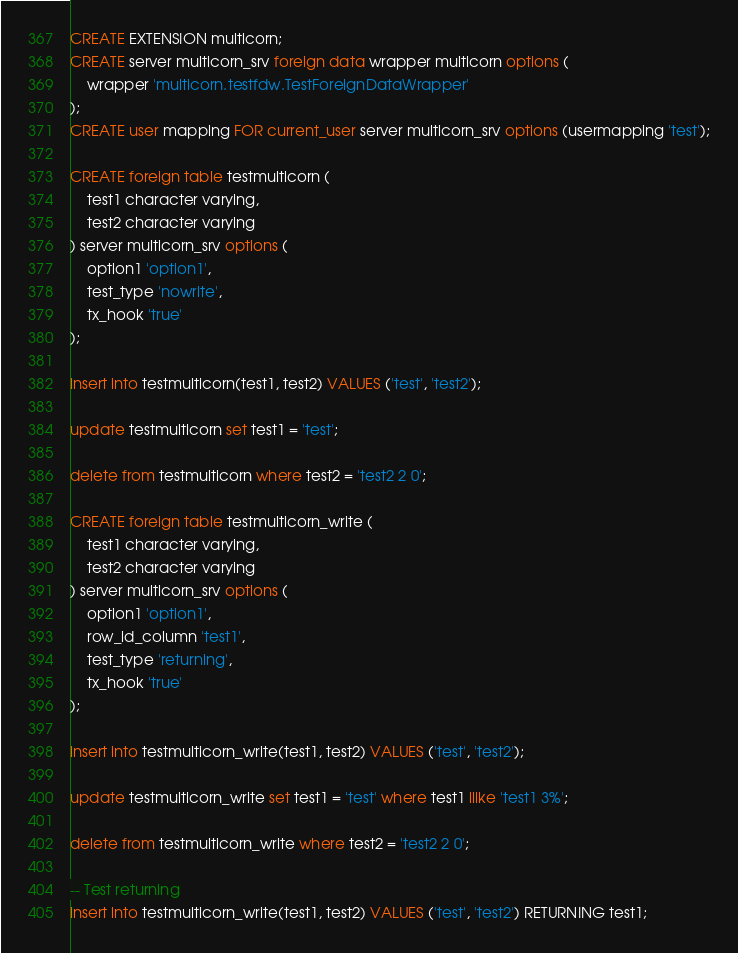<code> <loc_0><loc_0><loc_500><loc_500><_SQL_>CREATE EXTENSION multicorn;
CREATE server multicorn_srv foreign data wrapper multicorn options (
    wrapper 'multicorn.testfdw.TestForeignDataWrapper'
);
CREATE user mapping FOR current_user server multicorn_srv options (usermapping 'test');

CREATE foreign table testmulticorn (
    test1 character varying,
    test2 character varying
) server multicorn_srv options (
    option1 'option1',
    test_type 'nowrite',
    tx_hook 'true'
);

insert into testmulticorn(test1, test2) VALUES ('test', 'test2');

update testmulticorn set test1 = 'test';

delete from testmulticorn where test2 = 'test2 2 0';

CREATE foreign table testmulticorn_write (
    test1 character varying,
    test2 character varying
) server multicorn_srv options (
    option1 'option1',
    row_id_column 'test1',
	test_type 'returning',
    tx_hook 'true'
);

insert into testmulticorn_write(test1, test2) VALUES ('test', 'test2');

update testmulticorn_write set test1 = 'test' where test1 ilike 'test1 3%';

delete from testmulticorn_write where test2 = 'test2 2 0';

-- Test returning
insert into testmulticorn_write(test1, test2) VALUES ('test', 'test2') RETURNING test1;
</code> 